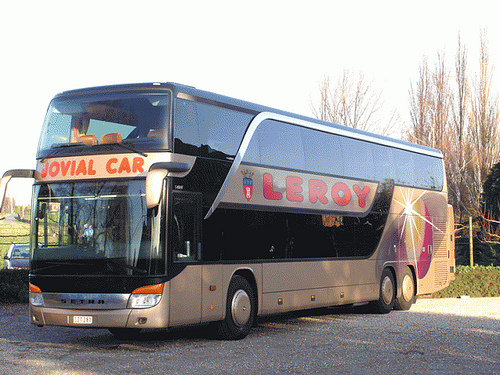Read all the text in this image. LEROY JOVIAL CAR 